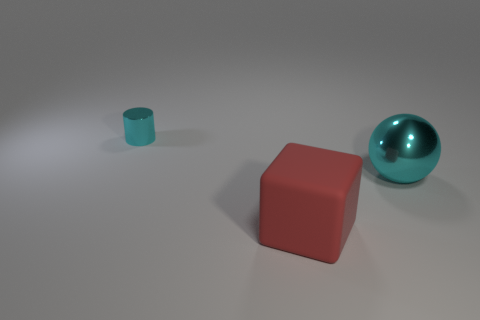Add 2 red objects. How many objects exist? 5 Subtract all cubes. How many objects are left? 2 Subtract all cubes. Subtract all metal cylinders. How many objects are left? 1 Add 1 big red cubes. How many big red cubes are left? 2 Add 1 tiny shiny objects. How many tiny shiny objects exist? 2 Subtract 0 gray cylinders. How many objects are left? 3 